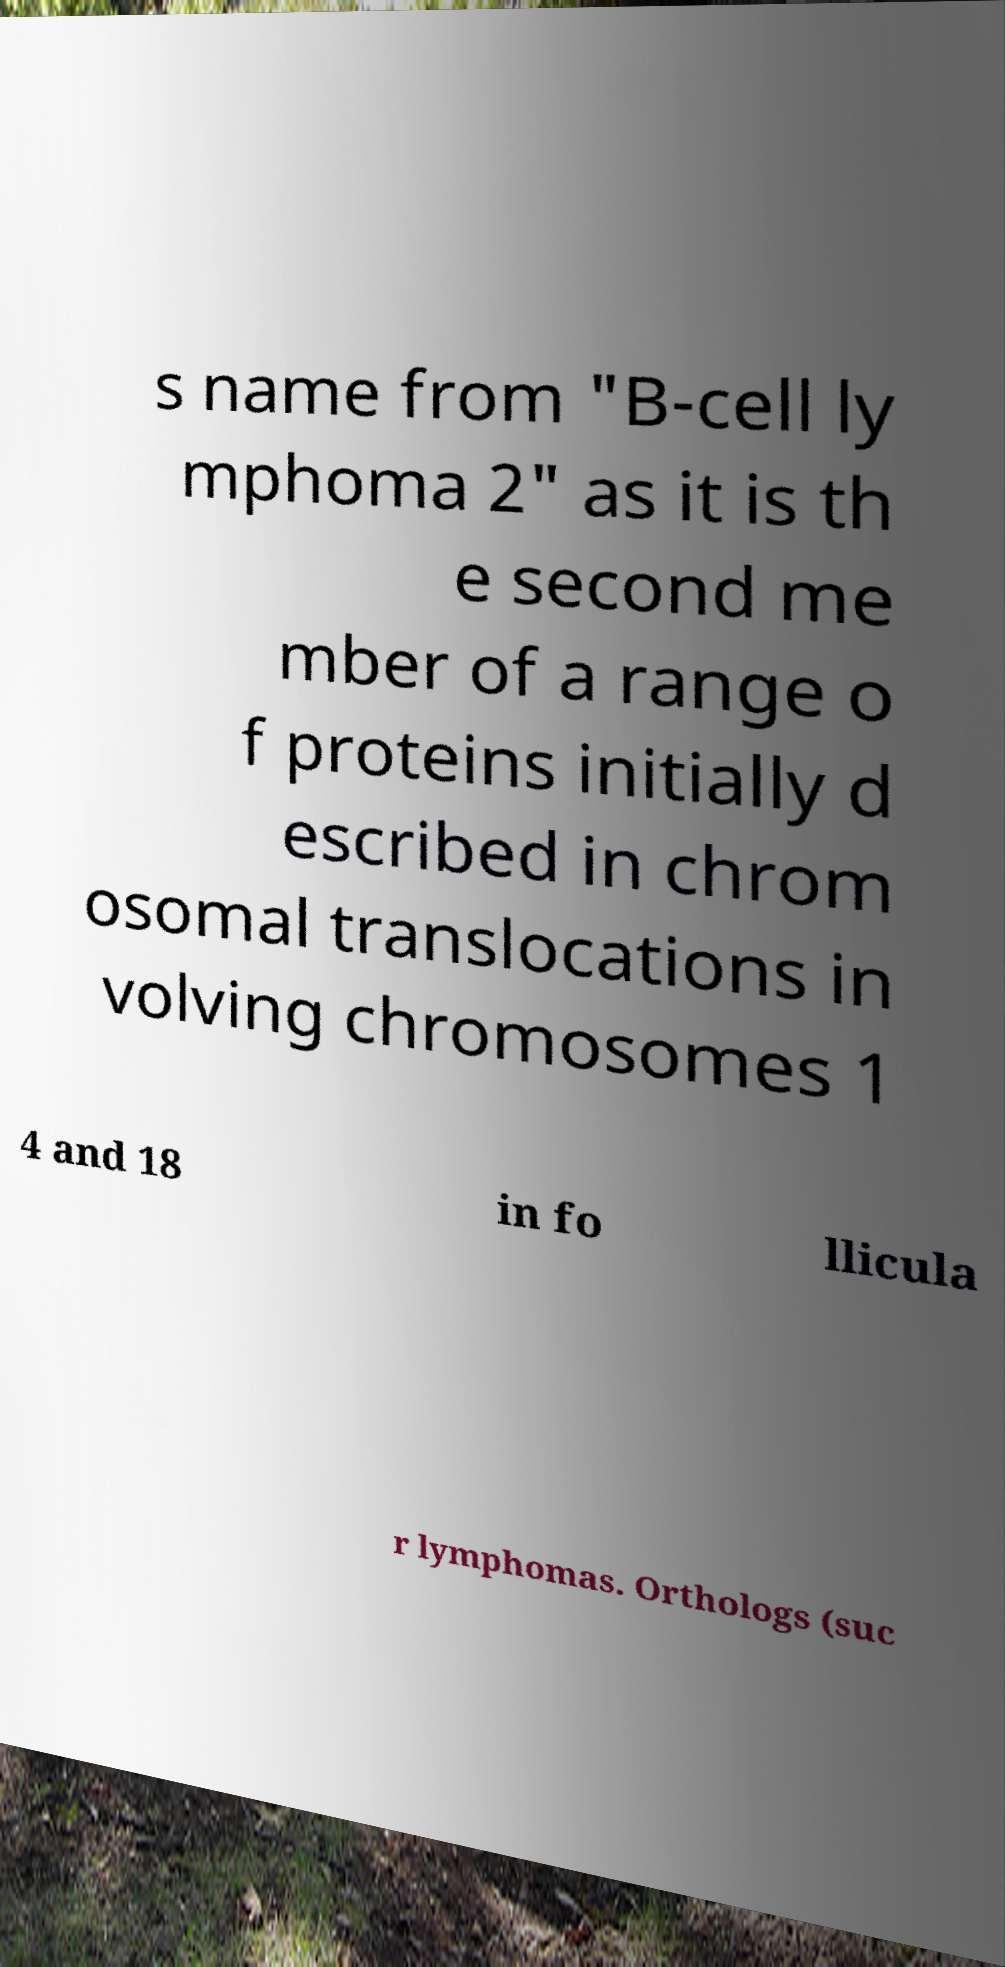Could you extract and type out the text from this image? s name from "B-cell ly mphoma 2" as it is th e second me mber of a range o f proteins initially d escribed in chrom osomal translocations in volving chromosomes 1 4 and 18 in fo llicula r lymphomas. Orthologs (suc 